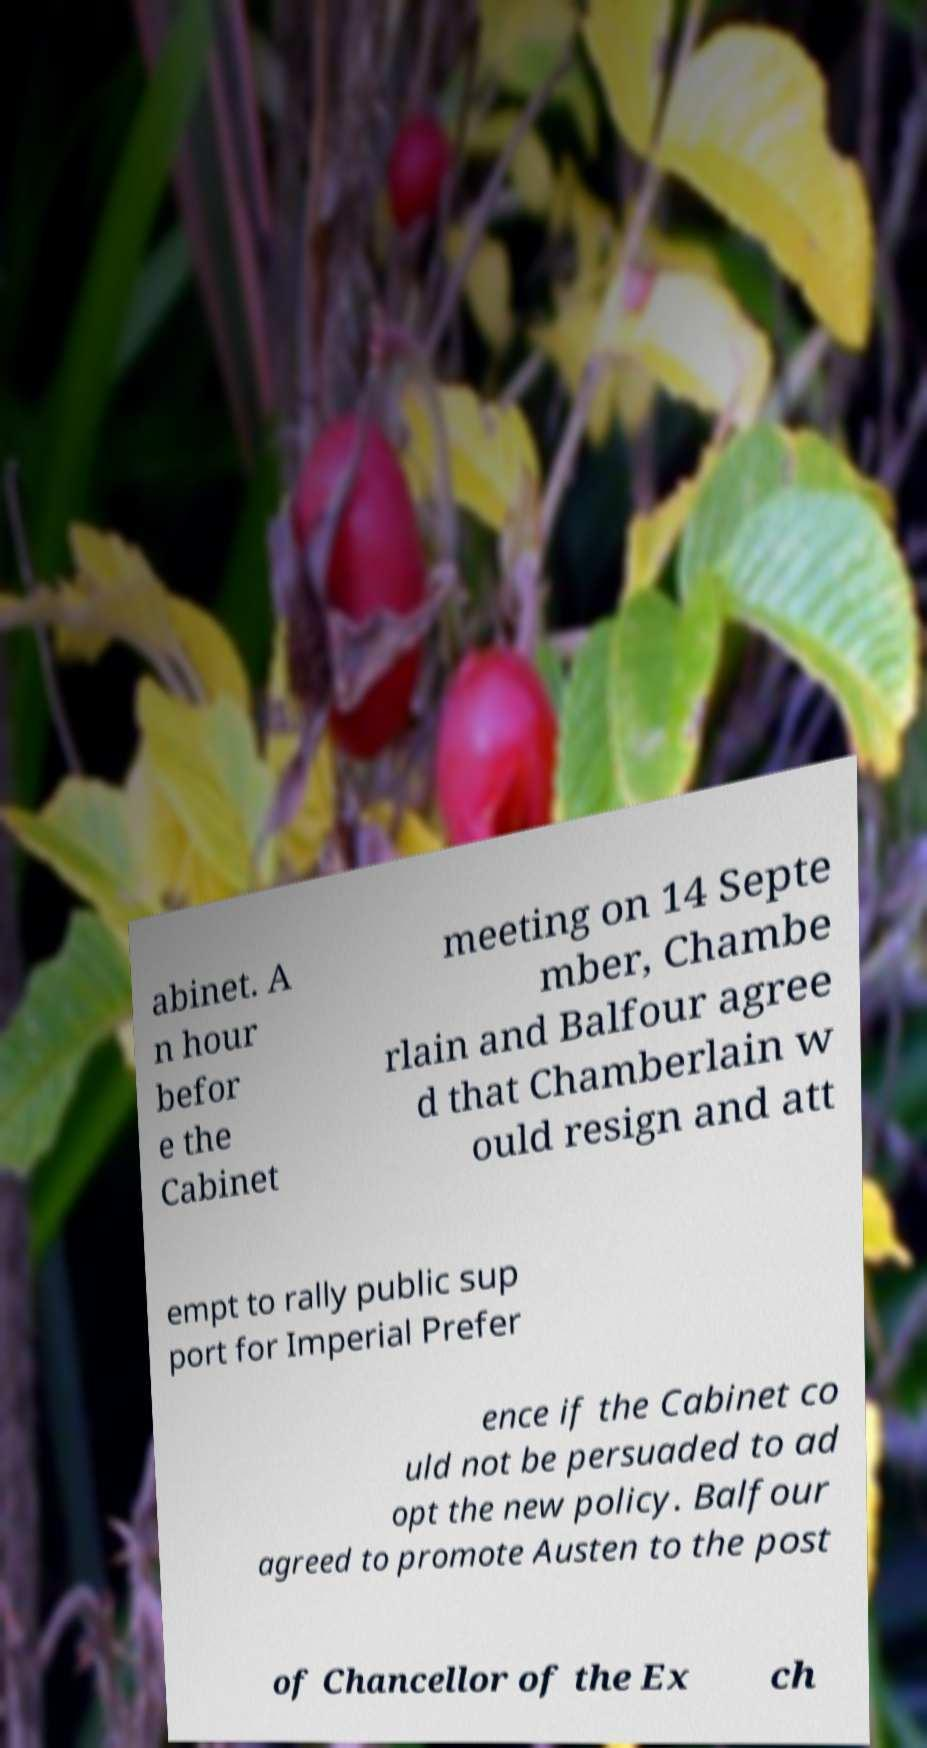What messages or text are displayed in this image? I need them in a readable, typed format. abinet. A n hour befor e the Cabinet meeting on 14 Septe mber, Chambe rlain and Balfour agree d that Chamberlain w ould resign and att empt to rally public sup port for Imperial Prefer ence if the Cabinet co uld not be persuaded to ad opt the new policy. Balfour agreed to promote Austen to the post of Chancellor of the Ex ch 